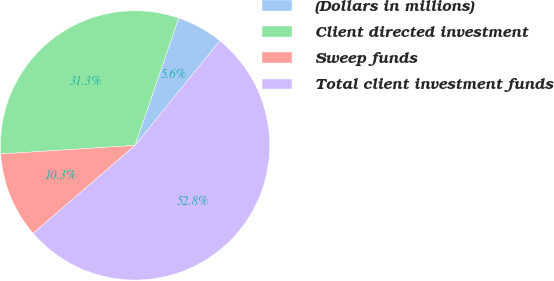Convert chart. <chart><loc_0><loc_0><loc_500><loc_500><pie_chart><fcel>(Dollars in millions)<fcel>Client directed investment<fcel>Sweep funds<fcel>Total client investment funds<nl><fcel>5.59%<fcel>31.27%<fcel>10.31%<fcel>52.83%<nl></chart> 